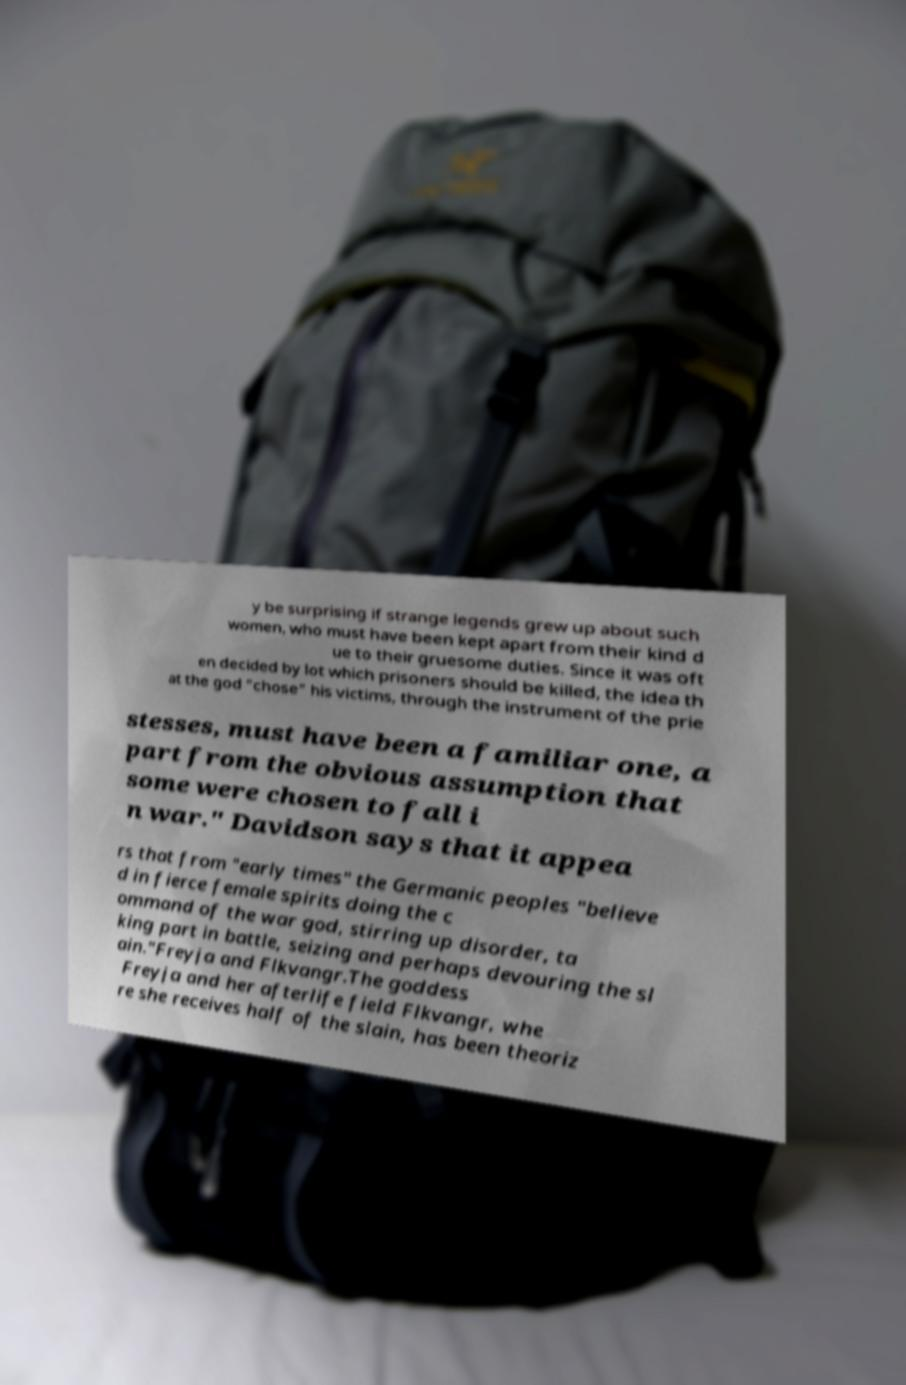For documentation purposes, I need the text within this image transcribed. Could you provide that? y be surprising if strange legends grew up about such women, who must have been kept apart from their kind d ue to their gruesome duties. Since it was oft en decided by lot which prisoners should be killed, the idea th at the god "chose" his victims, through the instrument of the prie stesses, must have been a familiar one, a part from the obvious assumption that some were chosen to fall i n war." Davidson says that it appea rs that from "early times" the Germanic peoples "believe d in fierce female spirits doing the c ommand of the war god, stirring up disorder, ta king part in battle, seizing and perhaps devouring the sl ain."Freyja and Flkvangr.The goddess Freyja and her afterlife field Flkvangr, whe re she receives half of the slain, has been theoriz 